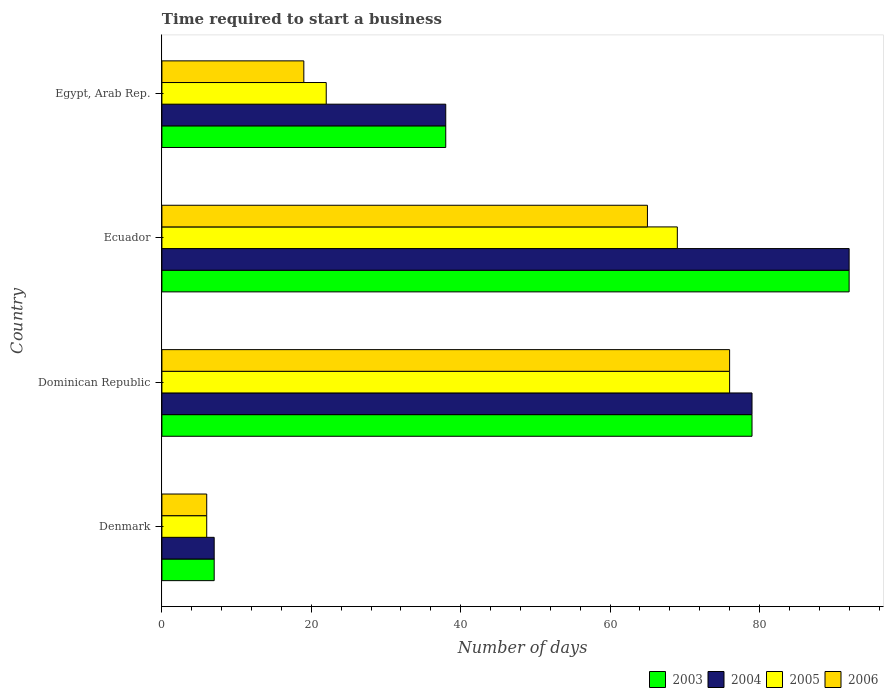How many groups of bars are there?
Make the answer very short. 4. How many bars are there on the 2nd tick from the bottom?
Your answer should be very brief. 4. What is the label of the 2nd group of bars from the top?
Provide a succinct answer. Ecuador. In how many cases, is the number of bars for a given country not equal to the number of legend labels?
Ensure brevity in your answer.  0. What is the number of days required to start a business in 2004 in Egypt, Arab Rep.?
Give a very brief answer. 38. Across all countries, what is the maximum number of days required to start a business in 2004?
Offer a very short reply. 92. Across all countries, what is the minimum number of days required to start a business in 2003?
Make the answer very short. 7. In which country was the number of days required to start a business in 2003 maximum?
Keep it short and to the point. Ecuador. In which country was the number of days required to start a business in 2004 minimum?
Make the answer very short. Denmark. What is the total number of days required to start a business in 2003 in the graph?
Provide a short and direct response. 216. What is the difference between the number of days required to start a business in 2006 in Dominican Republic and that in Egypt, Arab Rep.?
Your answer should be compact. 57. What is the difference between the number of days required to start a business in 2004 in Egypt, Arab Rep. and the number of days required to start a business in 2003 in Denmark?
Ensure brevity in your answer.  31. What is the average number of days required to start a business in 2005 per country?
Keep it short and to the point. 43.25. What is the difference between the number of days required to start a business in 2005 and number of days required to start a business in 2003 in Egypt, Arab Rep.?
Your response must be concise. -16. In how many countries, is the number of days required to start a business in 2006 greater than 84 days?
Ensure brevity in your answer.  0. What is the ratio of the number of days required to start a business in 2006 in Denmark to that in Dominican Republic?
Offer a terse response. 0.08. Is the number of days required to start a business in 2005 in Denmark less than that in Dominican Republic?
Offer a very short reply. Yes. What is the difference between the highest and the lowest number of days required to start a business in 2006?
Provide a succinct answer. 70. What does the 4th bar from the top in Dominican Republic represents?
Your answer should be very brief. 2003. Is it the case that in every country, the sum of the number of days required to start a business in 2004 and number of days required to start a business in 2003 is greater than the number of days required to start a business in 2006?
Your answer should be very brief. Yes. How many bars are there?
Make the answer very short. 16. How many countries are there in the graph?
Your answer should be compact. 4. What is the difference between two consecutive major ticks on the X-axis?
Your answer should be very brief. 20. Are the values on the major ticks of X-axis written in scientific E-notation?
Your answer should be compact. No. Does the graph contain grids?
Your answer should be very brief. No. How are the legend labels stacked?
Your response must be concise. Horizontal. What is the title of the graph?
Make the answer very short. Time required to start a business. Does "1967" appear as one of the legend labels in the graph?
Make the answer very short. No. What is the label or title of the X-axis?
Ensure brevity in your answer.  Number of days. What is the label or title of the Y-axis?
Your answer should be very brief. Country. What is the Number of days in 2004 in Denmark?
Keep it short and to the point. 7. What is the Number of days in 2006 in Denmark?
Provide a succinct answer. 6. What is the Number of days of 2003 in Dominican Republic?
Your answer should be very brief. 79. What is the Number of days of 2004 in Dominican Republic?
Give a very brief answer. 79. What is the Number of days in 2005 in Dominican Republic?
Provide a succinct answer. 76. What is the Number of days in 2003 in Ecuador?
Your answer should be very brief. 92. What is the Number of days of 2004 in Ecuador?
Provide a short and direct response. 92. What is the Number of days in 2005 in Ecuador?
Your response must be concise. 69. What is the Number of days of 2006 in Ecuador?
Give a very brief answer. 65. What is the Number of days in 2004 in Egypt, Arab Rep.?
Your response must be concise. 38. What is the Number of days in 2005 in Egypt, Arab Rep.?
Ensure brevity in your answer.  22. Across all countries, what is the maximum Number of days of 2003?
Your response must be concise. 92. Across all countries, what is the maximum Number of days of 2004?
Keep it short and to the point. 92. Across all countries, what is the minimum Number of days of 2005?
Keep it short and to the point. 6. What is the total Number of days in 2003 in the graph?
Provide a succinct answer. 216. What is the total Number of days in 2004 in the graph?
Provide a short and direct response. 216. What is the total Number of days of 2005 in the graph?
Keep it short and to the point. 173. What is the total Number of days in 2006 in the graph?
Give a very brief answer. 166. What is the difference between the Number of days in 2003 in Denmark and that in Dominican Republic?
Offer a very short reply. -72. What is the difference between the Number of days of 2004 in Denmark and that in Dominican Republic?
Keep it short and to the point. -72. What is the difference between the Number of days of 2005 in Denmark and that in Dominican Republic?
Offer a terse response. -70. What is the difference between the Number of days in 2006 in Denmark and that in Dominican Republic?
Your answer should be compact. -70. What is the difference between the Number of days in 2003 in Denmark and that in Ecuador?
Give a very brief answer. -85. What is the difference between the Number of days in 2004 in Denmark and that in Ecuador?
Ensure brevity in your answer.  -85. What is the difference between the Number of days in 2005 in Denmark and that in Ecuador?
Make the answer very short. -63. What is the difference between the Number of days in 2006 in Denmark and that in Ecuador?
Provide a short and direct response. -59. What is the difference between the Number of days of 2003 in Denmark and that in Egypt, Arab Rep.?
Make the answer very short. -31. What is the difference between the Number of days in 2004 in Denmark and that in Egypt, Arab Rep.?
Provide a short and direct response. -31. What is the difference between the Number of days in 2005 in Denmark and that in Egypt, Arab Rep.?
Offer a very short reply. -16. What is the difference between the Number of days in 2003 in Dominican Republic and that in Ecuador?
Ensure brevity in your answer.  -13. What is the difference between the Number of days of 2006 in Dominican Republic and that in Ecuador?
Your answer should be very brief. 11. What is the difference between the Number of days in 2003 in Dominican Republic and that in Egypt, Arab Rep.?
Offer a very short reply. 41. What is the difference between the Number of days of 2005 in Dominican Republic and that in Egypt, Arab Rep.?
Make the answer very short. 54. What is the difference between the Number of days of 2006 in Dominican Republic and that in Egypt, Arab Rep.?
Make the answer very short. 57. What is the difference between the Number of days of 2004 in Ecuador and that in Egypt, Arab Rep.?
Give a very brief answer. 54. What is the difference between the Number of days of 2006 in Ecuador and that in Egypt, Arab Rep.?
Offer a very short reply. 46. What is the difference between the Number of days of 2003 in Denmark and the Number of days of 2004 in Dominican Republic?
Your answer should be very brief. -72. What is the difference between the Number of days of 2003 in Denmark and the Number of days of 2005 in Dominican Republic?
Offer a terse response. -69. What is the difference between the Number of days of 2003 in Denmark and the Number of days of 2006 in Dominican Republic?
Ensure brevity in your answer.  -69. What is the difference between the Number of days in 2004 in Denmark and the Number of days in 2005 in Dominican Republic?
Make the answer very short. -69. What is the difference between the Number of days in 2004 in Denmark and the Number of days in 2006 in Dominican Republic?
Make the answer very short. -69. What is the difference between the Number of days of 2005 in Denmark and the Number of days of 2006 in Dominican Republic?
Your answer should be compact. -70. What is the difference between the Number of days in 2003 in Denmark and the Number of days in 2004 in Ecuador?
Your response must be concise. -85. What is the difference between the Number of days of 2003 in Denmark and the Number of days of 2005 in Ecuador?
Provide a short and direct response. -62. What is the difference between the Number of days in 2003 in Denmark and the Number of days in 2006 in Ecuador?
Make the answer very short. -58. What is the difference between the Number of days of 2004 in Denmark and the Number of days of 2005 in Ecuador?
Your response must be concise. -62. What is the difference between the Number of days in 2004 in Denmark and the Number of days in 2006 in Ecuador?
Your answer should be very brief. -58. What is the difference between the Number of days of 2005 in Denmark and the Number of days of 2006 in Ecuador?
Give a very brief answer. -59. What is the difference between the Number of days in 2003 in Denmark and the Number of days in 2004 in Egypt, Arab Rep.?
Offer a terse response. -31. What is the difference between the Number of days in 2003 in Denmark and the Number of days in 2005 in Egypt, Arab Rep.?
Provide a short and direct response. -15. What is the difference between the Number of days in 2004 in Denmark and the Number of days in 2005 in Egypt, Arab Rep.?
Make the answer very short. -15. What is the difference between the Number of days of 2003 in Dominican Republic and the Number of days of 2006 in Ecuador?
Ensure brevity in your answer.  14. What is the difference between the Number of days of 2004 in Dominican Republic and the Number of days of 2005 in Ecuador?
Ensure brevity in your answer.  10. What is the difference between the Number of days of 2004 in Dominican Republic and the Number of days of 2006 in Ecuador?
Offer a terse response. 14. What is the difference between the Number of days in 2003 in Dominican Republic and the Number of days in 2004 in Egypt, Arab Rep.?
Provide a succinct answer. 41. What is the difference between the Number of days of 2004 in Dominican Republic and the Number of days of 2006 in Egypt, Arab Rep.?
Give a very brief answer. 60. What is the difference between the Number of days of 2003 in Ecuador and the Number of days of 2004 in Egypt, Arab Rep.?
Your response must be concise. 54. What is the difference between the Number of days of 2004 in Ecuador and the Number of days of 2005 in Egypt, Arab Rep.?
Your response must be concise. 70. What is the average Number of days of 2005 per country?
Your response must be concise. 43.25. What is the average Number of days in 2006 per country?
Your answer should be very brief. 41.5. What is the difference between the Number of days in 2004 and Number of days in 2005 in Denmark?
Provide a succinct answer. 1. What is the difference between the Number of days in 2004 and Number of days in 2006 in Denmark?
Your answer should be compact. 1. What is the difference between the Number of days in 2005 and Number of days in 2006 in Denmark?
Provide a succinct answer. 0. What is the difference between the Number of days of 2003 and Number of days of 2006 in Dominican Republic?
Give a very brief answer. 3. What is the difference between the Number of days of 2003 and Number of days of 2005 in Ecuador?
Provide a short and direct response. 23. What is the difference between the Number of days of 2003 and Number of days of 2006 in Ecuador?
Offer a terse response. 27. What is the difference between the Number of days in 2004 and Number of days in 2006 in Ecuador?
Keep it short and to the point. 27. What is the difference between the Number of days in 2003 and Number of days in 2004 in Egypt, Arab Rep.?
Give a very brief answer. 0. What is the difference between the Number of days of 2004 and Number of days of 2005 in Egypt, Arab Rep.?
Your answer should be compact. 16. What is the difference between the Number of days of 2005 and Number of days of 2006 in Egypt, Arab Rep.?
Make the answer very short. 3. What is the ratio of the Number of days of 2003 in Denmark to that in Dominican Republic?
Provide a short and direct response. 0.09. What is the ratio of the Number of days of 2004 in Denmark to that in Dominican Republic?
Keep it short and to the point. 0.09. What is the ratio of the Number of days of 2005 in Denmark to that in Dominican Republic?
Provide a succinct answer. 0.08. What is the ratio of the Number of days in 2006 in Denmark to that in Dominican Republic?
Ensure brevity in your answer.  0.08. What is the ratio of the Number of days of 2003 in Denmark to that in Ecuador?
Your answer should be compact. 0.08. What is the ratio of the Number of days in 2004 in Denmark to that in Ecuador?
Offer a terse response. 0.08. What is the ratio of the Number of days of 2005 in Denmark to that in Ecuador?
Provide a succinct answer. 0.09. What is the ratio of the Number of days in 2006 in Denmark to that in Ecuador?
Give a very brief answer. 0.09. What is the ratio of the Number of days in 2003 in Denmark to that in Egypt, Arab Rep.?
Offer a very short reply. 0.18. What is the ratio of the Number of days in 2004 in Denmark to that in Egypt, Arab Rep.?
Your answer should be compact. 0.18. What is the ratio of the Number of days in 2005 in Denmark to that in Egypt, Arab Rep.?
Ensure brevity in your answer.  0.27. What is the ratio of the Number of days of 2006 in Denmark to that in Egypt, Arab Rep.?
Keep it short and to the point. 0.32. What is the ratio of the Number of days of 2003 in Dominican Republic to that in Ecuador?
Your answer should be compact. 0.86. What is the ratio of the Number of days of 2004 in Dominican Republic to that in Ecuador?
Your response must be concise. 0.86. What is the ratio of the Number of days of 2005 in Dominican Republic to that in Ecuador?
Keep it short and to the point. 1.1. What is the ratio of the Number of days in 2006 in Dominican Republic to that in Ecuador?
Provide a short and direct response. 1.17. What is the ratio of the Number of days in 2003 in Dominican Republic to that in Egypt, Arab Rep.?
Give a very brief answer. 2.08. What is the ratio of the Number of days of 2004 in Dominican Republic to that in Egypt, Arab Rep.?
Ensure brevity in your answer.  2.08. What is the ratio of the Number of days of 2005 in Dominican Republic to that in Egypt, Arab Rep.?
Your answer should be very brief. 3.45. What is the ratio of the Number of days in 2003 in Ecuador to that in Egypt, Arab Rep.?
Your response must be concise. 2.42. What is the ratio of the Number of days of 2004 in Ecuador to that in Egypt, Arab Rep.?
Ensure brevity in your answer.  2.42. What is the ratio of the Number of days in 2005 in Ecuador to that in Egypt, Arab Rep.?
Your answer should be compact. 3.14. What is the ratio of the Number of days in 2006 in Ecuador to that in Egypt, Arab Rep.?
Your answer should be very brief. 3.42. What is the difference between the highest and the second highest Number of days of 2005?
Provide a succinct answer. 7. What is the difference between the highest and the lowest Number of days of 2003?
Keep it short and to the point. 85. What is the difference between the highest and the lowest Number of days in 2006?
Offer a terse response. 70. 